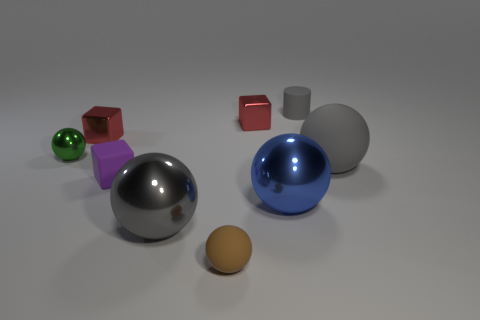Is there anything else that has the same shape as the small gray thing?
Offer a very short reply. No. Are the blue sphere and the cube on the left side of the small purple block made of the same material?
Offer a terse response. Yes. What is the color of the shiny sphere that is both to the left of the big blue metal ball and to the right of the green metallic sphere?
Provide a short and direct response. Gray. How many balls are big things or small purple rubber objects?
Provide a short and direct response. 3. There is a large blue thing; does it have the same shape as the gray thing behind the small metallic ball?
Your response must be concise. No. What size is the ball that is right of the gray metallic object and in front of the blue shiny thing?
Provide a succinct answer. Small. The tiny green object is what shape?
Provide a succinct answer. Sphere. Is there a gray sphere in front of the big shiny thing left of the brown rubber thing?
Ensure brevity in your answer.  No. How many red objects are to the right of the small metal block right of the brown rubber ball?
Offer a terse response. 0. There is a green ball that is the same size as the brown thing; what is it made of?
Your response must be concise. Metal. 